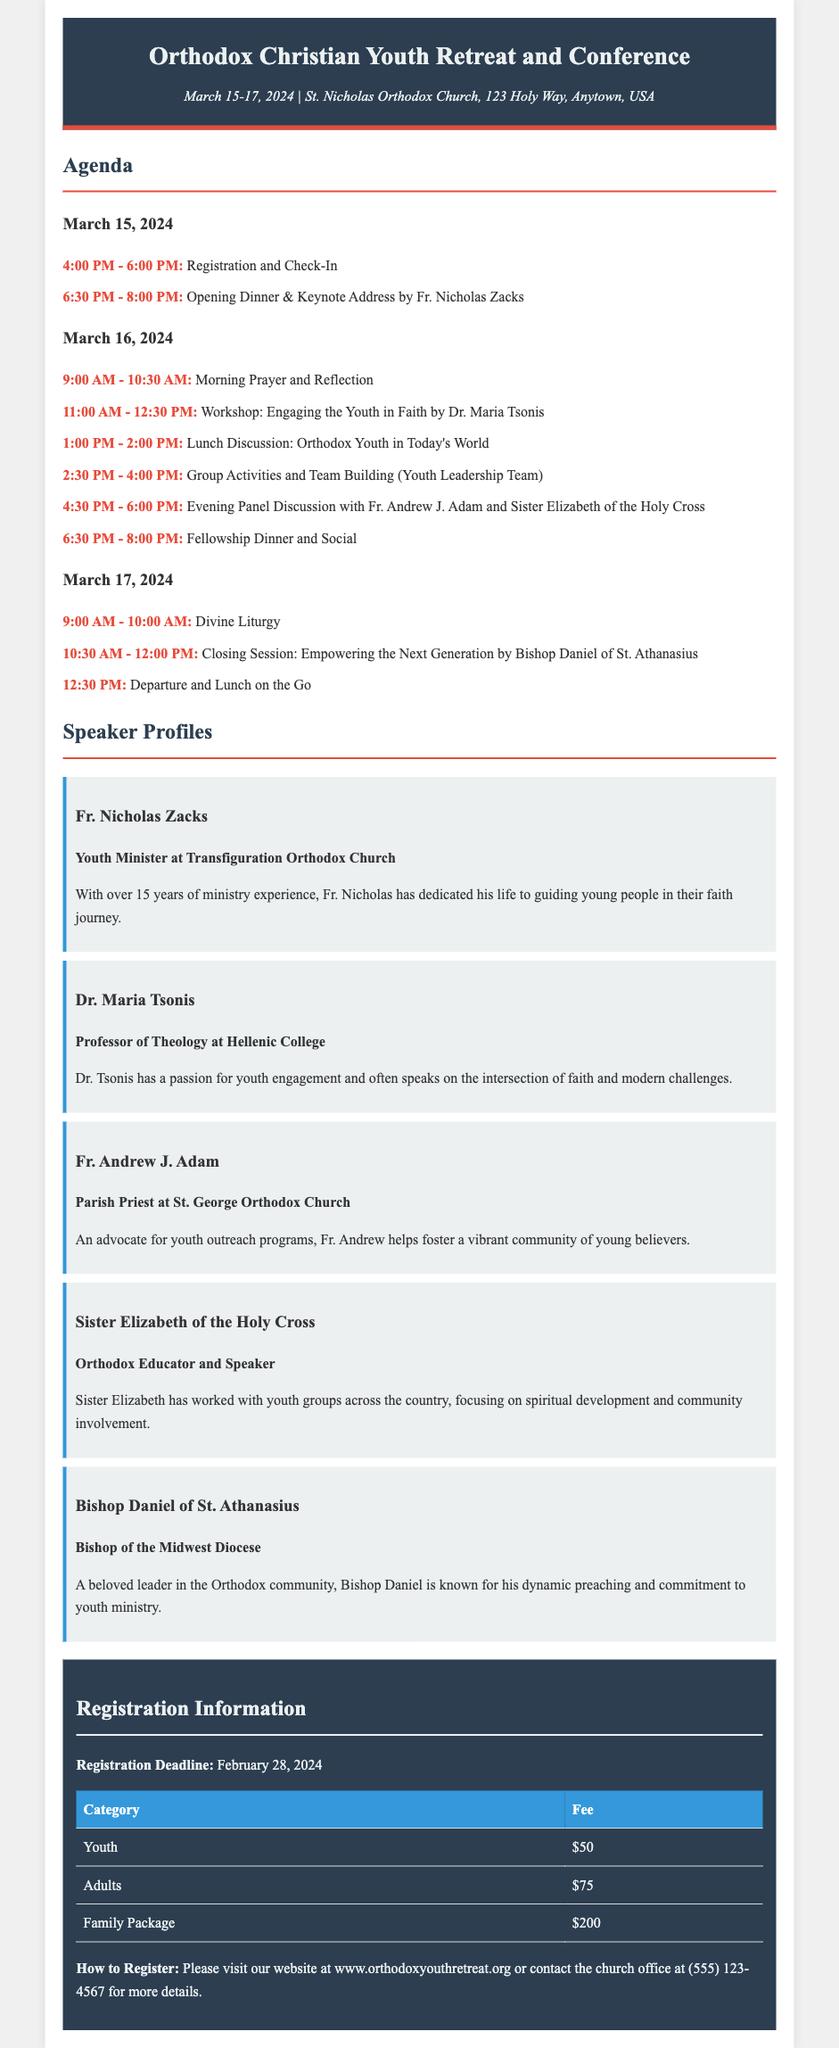What are the dates of the retreat? The retreat takes place from March 15-17, 2024.
Answer: March 15-17, 2024 Who is the keynote speaker for the opening dinner? The keynote address will be delivered by Fr. Nicholas Zacks during the opening dinner.
Answer: Fr. Nicholas Zacks What time does registration start on March 15, 2024? Registration and check-in begin at 4:00 PM on March 15, 2024.
Answer: 4:00 PM What is the fee for youth registration? The document states that the fee for youth registration is $50.
Answer: $50 How long is the morning prayer and reflection session on March 16, 2024? The session lasts for 1.5 hours, from 9:00 AM to 10:30 AM.
Answer: 1.5 hours Who are the speakers in the evening panel discussion? The evening panel discussion features Fr. Andrew J. Adam and Sister Elizabeth of the Holy Cross.
Answer: Fr. Andrew J. Adam and Sister Elizabeth of the Holy Cross What is the registration deadline? The registration deadline is specified as February 28, 2024.
Answer: February 28, 2024 What is the family package registration fee? The family package registration fee is listed as $200.
Answer: $200 What is the focus of Dr. Maria Tsonis's workshop? The workshop that Dr. Maria Tsonis is leading focuses on engaging youth in faith.
Answer: Engaging the Youth in Faith 